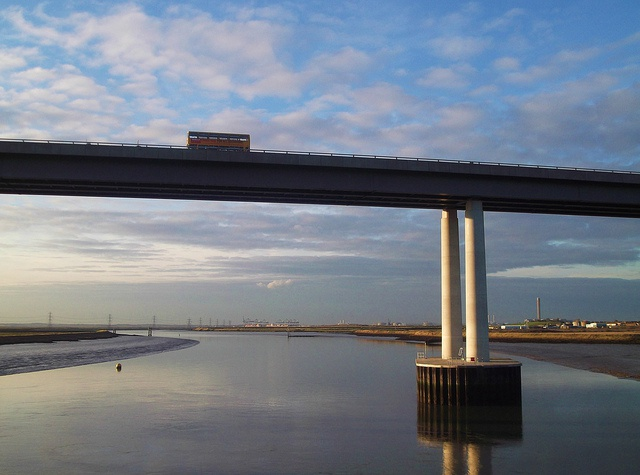Describe the objects in this image and their specific colors. I can see bus in darkgray, maroon, black, and gray tones in this image. 